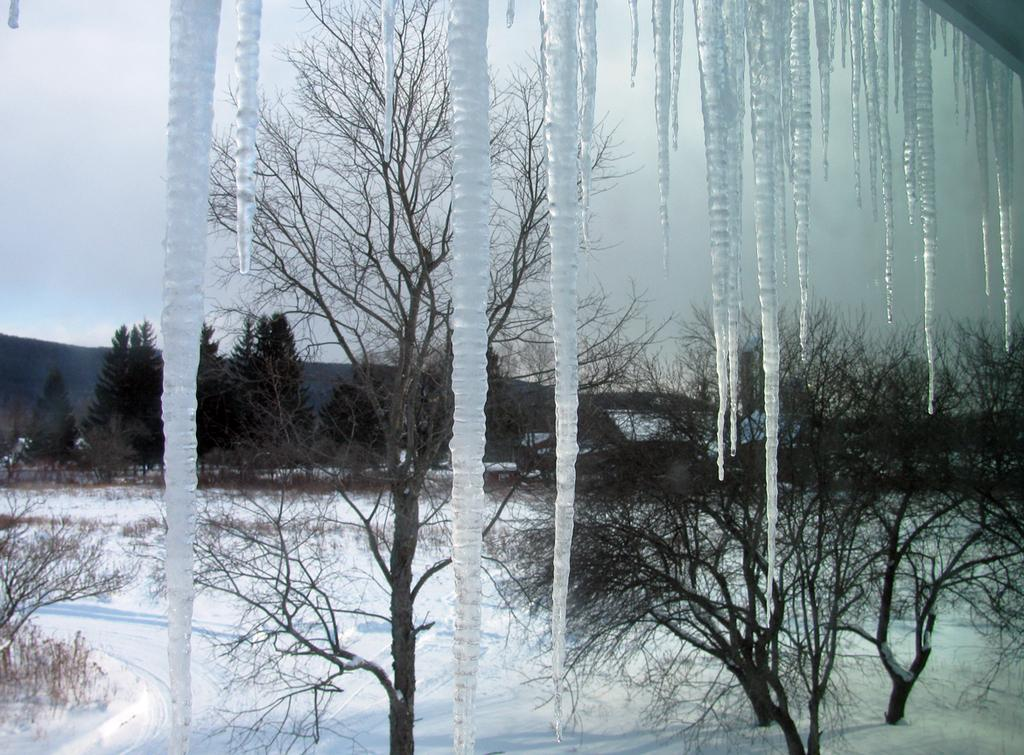What is the main structure in the center of the image? There is a snow stand in the center of the image. What type of natural elements can be seen in the image? There are trees and snow on the ground visible in the image. What is visible in the background of the image? There are trees in the background of the image. What color is the crayon used to draw the pot in the image? There is no crayon or pot present in the image. What level of difficulty is the image rated on a scale of 1 to 10? The image is not rated on a scale of difficulty, as it is a photograph and not a game or challenge. 